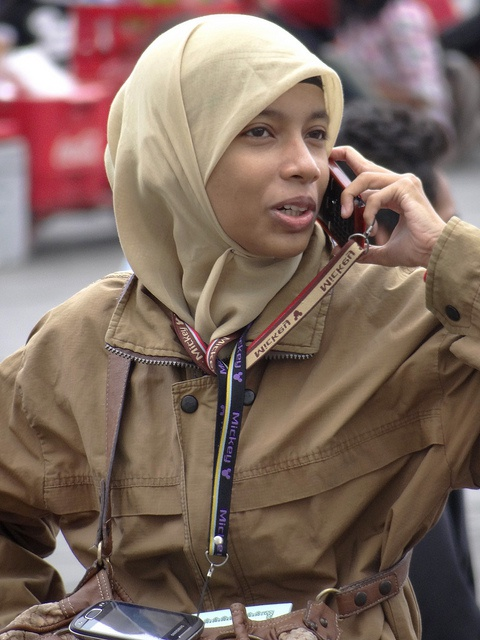Describe the objects in this image and their specific colors. I can see people in black, gray, and maroon tones, people in black, gray, and darkgray tones, cell phone in black, gray, and white tones, and cell phone in black, maroon, gray, and lavender tones in this image. 